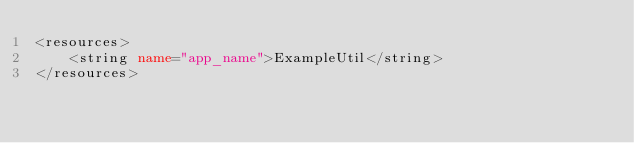<code> <loc_0><loc_0><loc_500><loc_500><_XML_><resources>
    <string name="app_name">ExampleUtil</string>
</resources>
</code> 